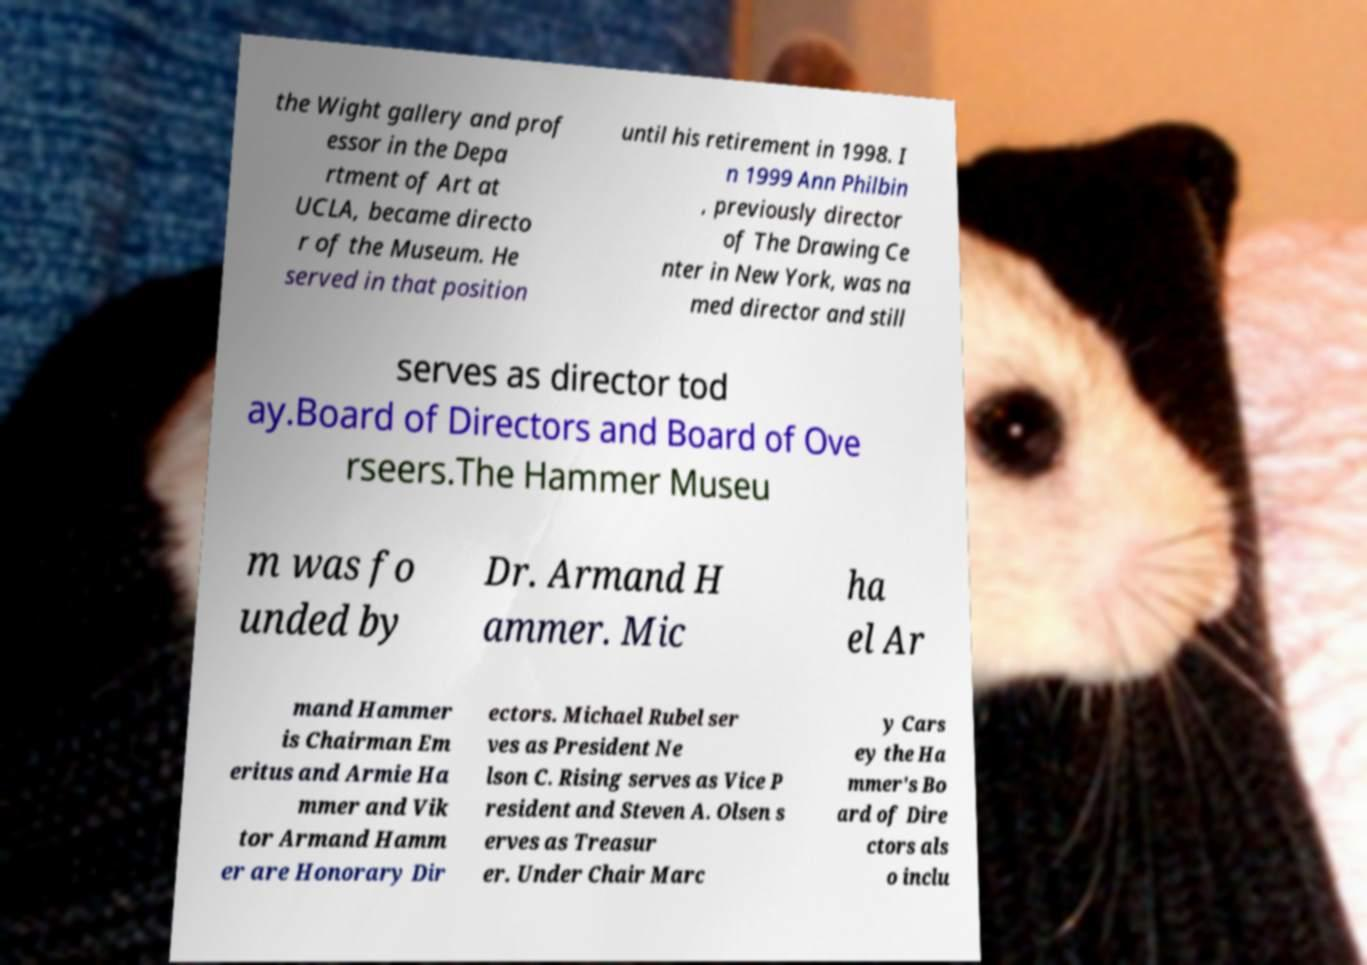Can you read and provide the text displayed in the image?This photo seems to have some interesting text. Can you extract and type it out for me? the Wight gallery and prof essor in the Depa rtment of Art at UCLA, became directo r of the Museum. He served in that position until his retirement in 1998. I n 1999 Ann Philbin , previously director of The Drawing Ce nter in New York, was na med director and still serves as director tod ay.Board of Directors and Board of Ove rseers.The Hammer Museu m was fo unded by Dr. Armand H ammer. Mic ha el Ar mand Hammer is Chairman Em eritus and Armie Ha mmer and Vik tor Armand Hamm er are Honorary Dir ectors. Michael Rubel ser ves as President Ne lson C. Rising serves as Vice P resident and Steven A. Olsen s erves as Treasur er. Under Chair Marc y Cars ey the Ha mmer's Bo ard of Dire ctors als o inclu 